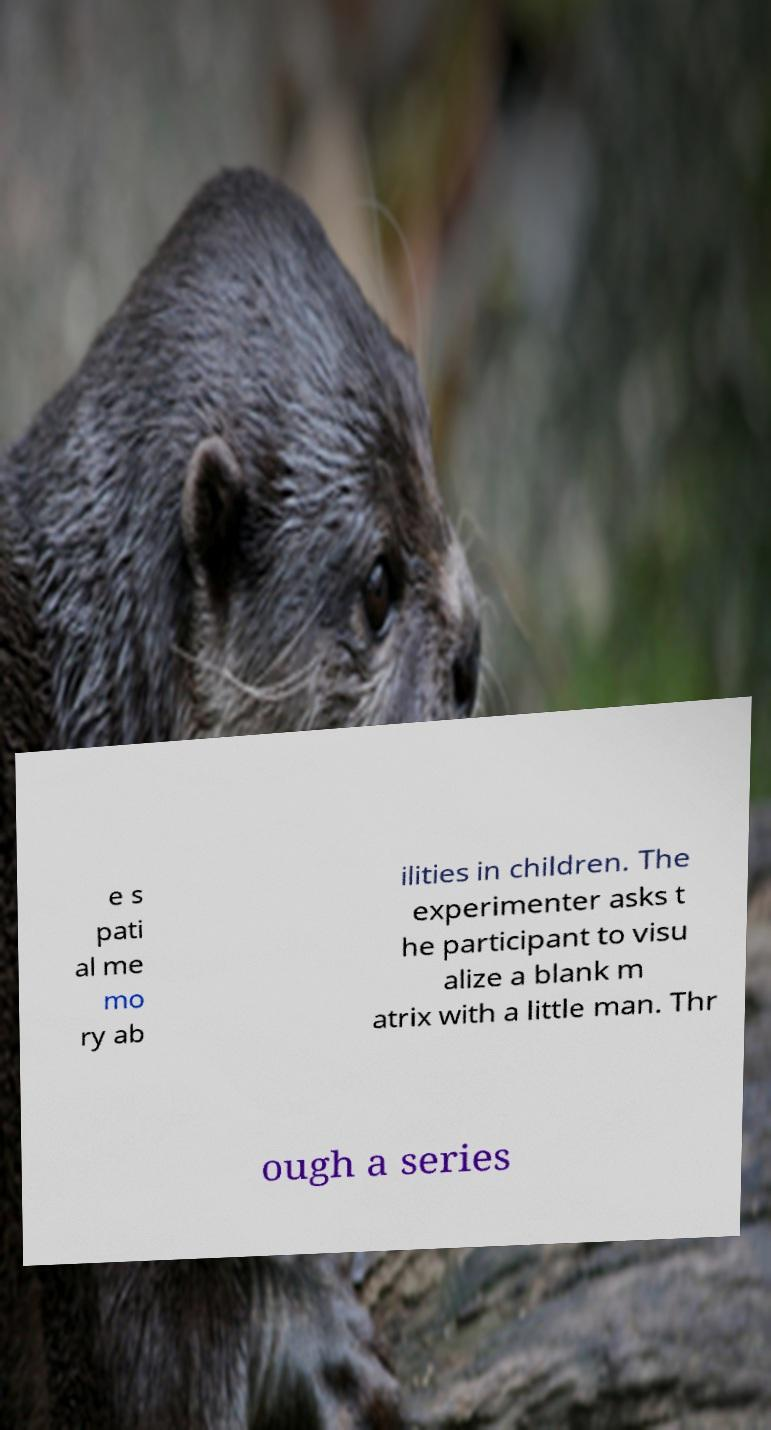For documentation purposes, I need the text within this image transcribed. Could you provide that? e s pati al me mo ry ab ilities in children. The experimenter asks t he participant to visu alize a blank m atrix with a little man. Thr ough a series 